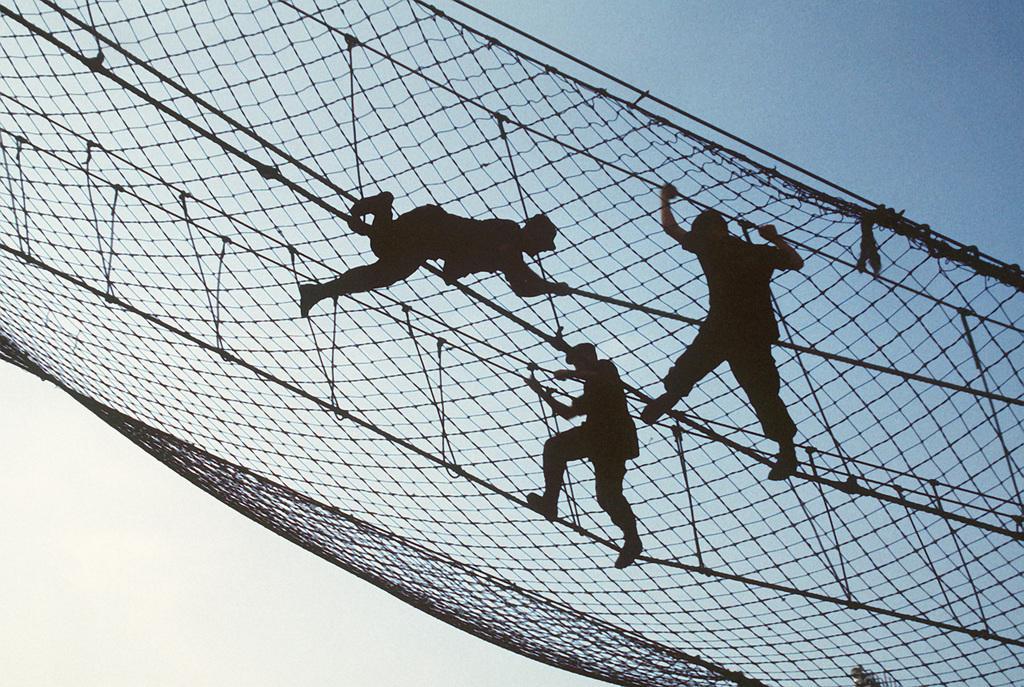Can you describe this image briefly? In the center of this picture we can see the group of people seems to be climbing the net and we can see the ropes and some other objects. In the background we can see the sky. 